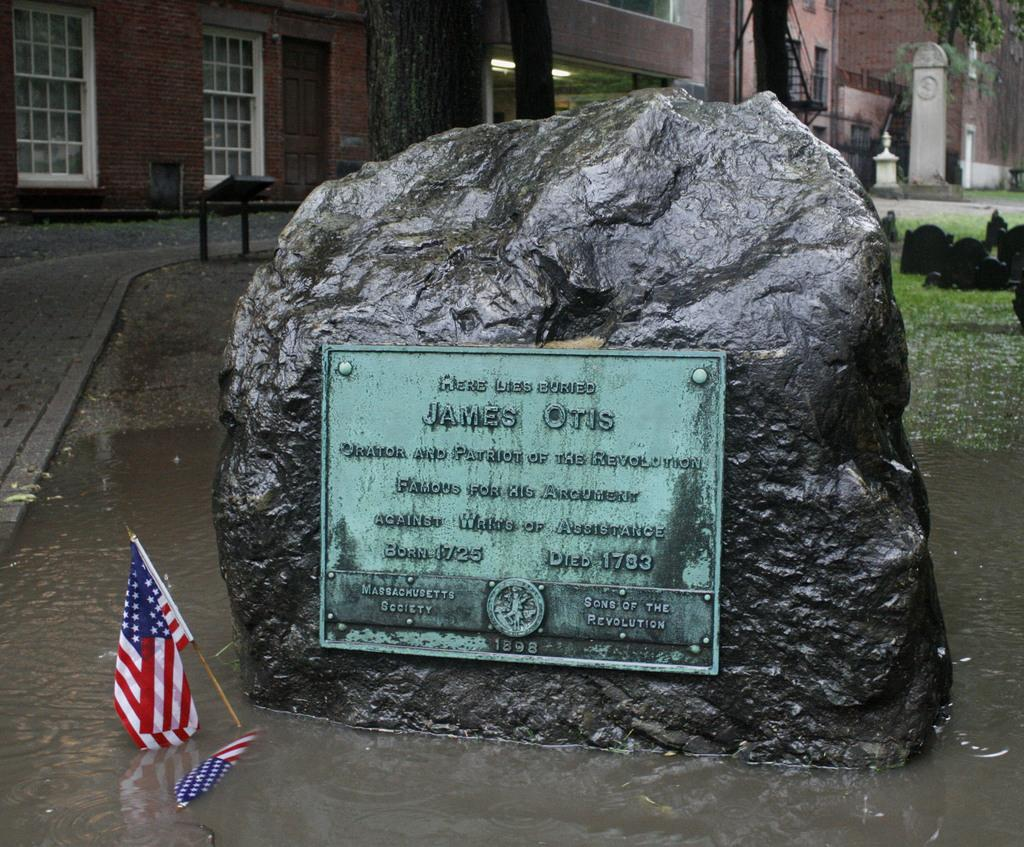What is located in the water in the image? There is a rock with a text board in the water. What can be seen flying in the image? Flags are visible in the image. What type of structures are present in the image? There are buildings in the image. What type of vegetation is present in the image? Trees are present in the image. What type of surface is visible in the image? There is a path in the image. What type of illumination is visible in the image? Lights are visible in the image. How many sticks are being used by the cook in the image? There is no cook or sticks present in the image. What type of bells can be heard ringing in the image? There are no bells present in the image, and therefore no sound can be heard. 